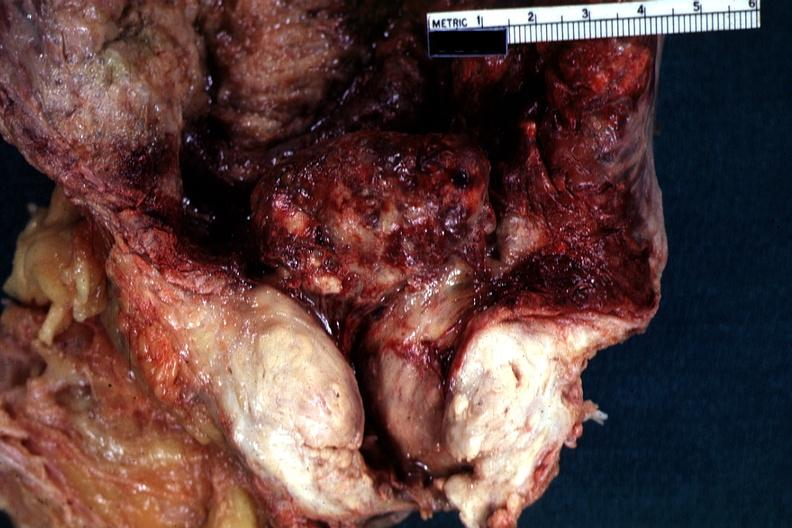what is present?
Answer the question using a single word or phrase. Hyperplasia median bar 